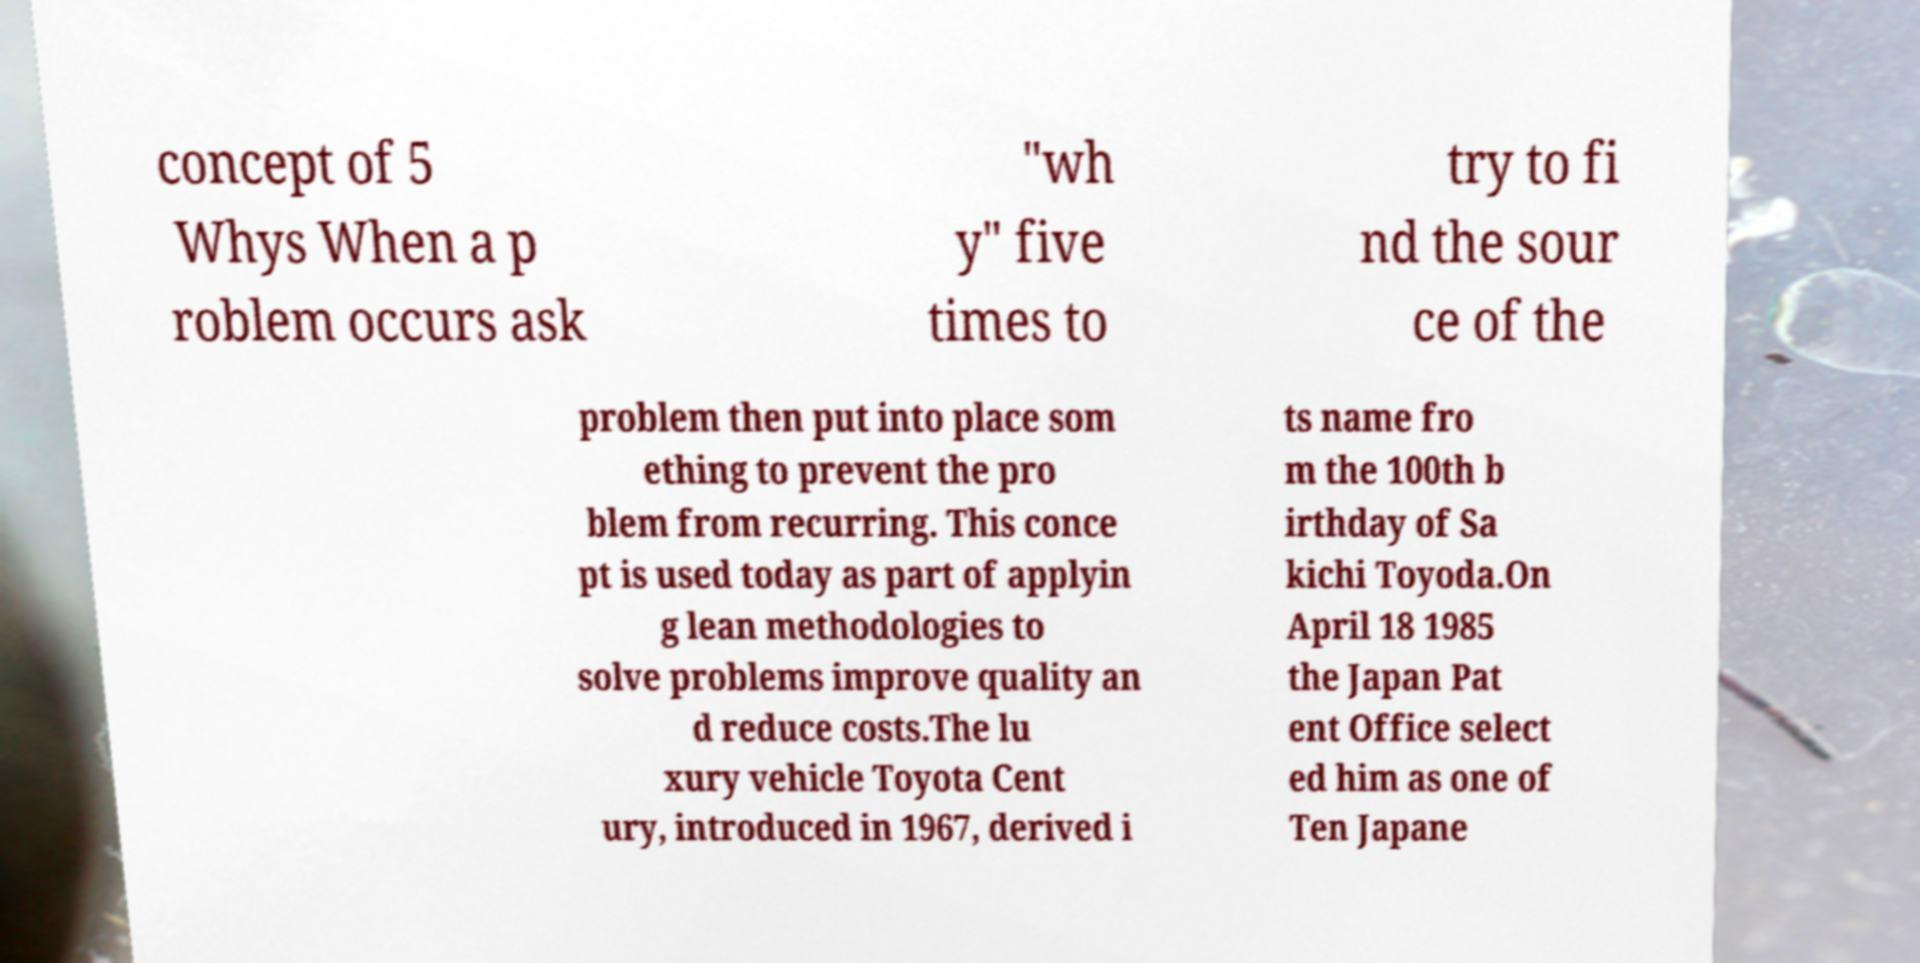Can you accurately transcribe the text from the provided image for me? concept of 5 Whys When a p roblem occurs ask "wh y" five times to try to fi nd the sour ce of the problem then put into place som ething to prevent the pro blem from recurring. This conce pt is used today as part of applyin g lean methodologies to solve problems improve quality an d reduce costs.The lu xury vehicle Toyota Cent ury, introduced in 1967, derived i ts name fro m the 100th b irthday of Sa kichi Toyoda.On April 18 1985 the Japan Pat ent Office select ed him as one of Ten Japane 